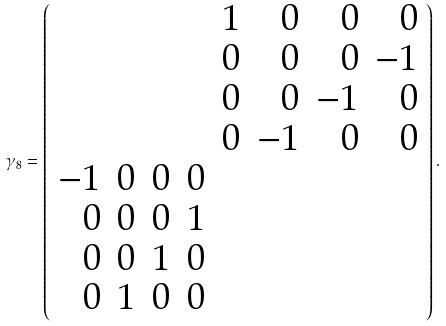Convert formula to latex. <formula><loc_0><loc_0><loc_500><loc_500>\gamma _ { 8 } = \left ( \begin{array} { r r r r r r r r } & & & & 1 & 0 & 0 & 0 \\ & & & & 0 & 0 & 0 & - 1 \\ & & & & 0 & 0 & - 1 & 0 \\ & & & & 0 & - 1 & 0 & 0 \\ - 1 & 0 & 0 & 0 & & & & \\ 0 & 0 & 0 & 1 & & & & \\ 0 & 0 & 1 & 0 & & & & \\ 0 & 1 & 0 & 0 & & & & \end{array} \right ) .</formula> 